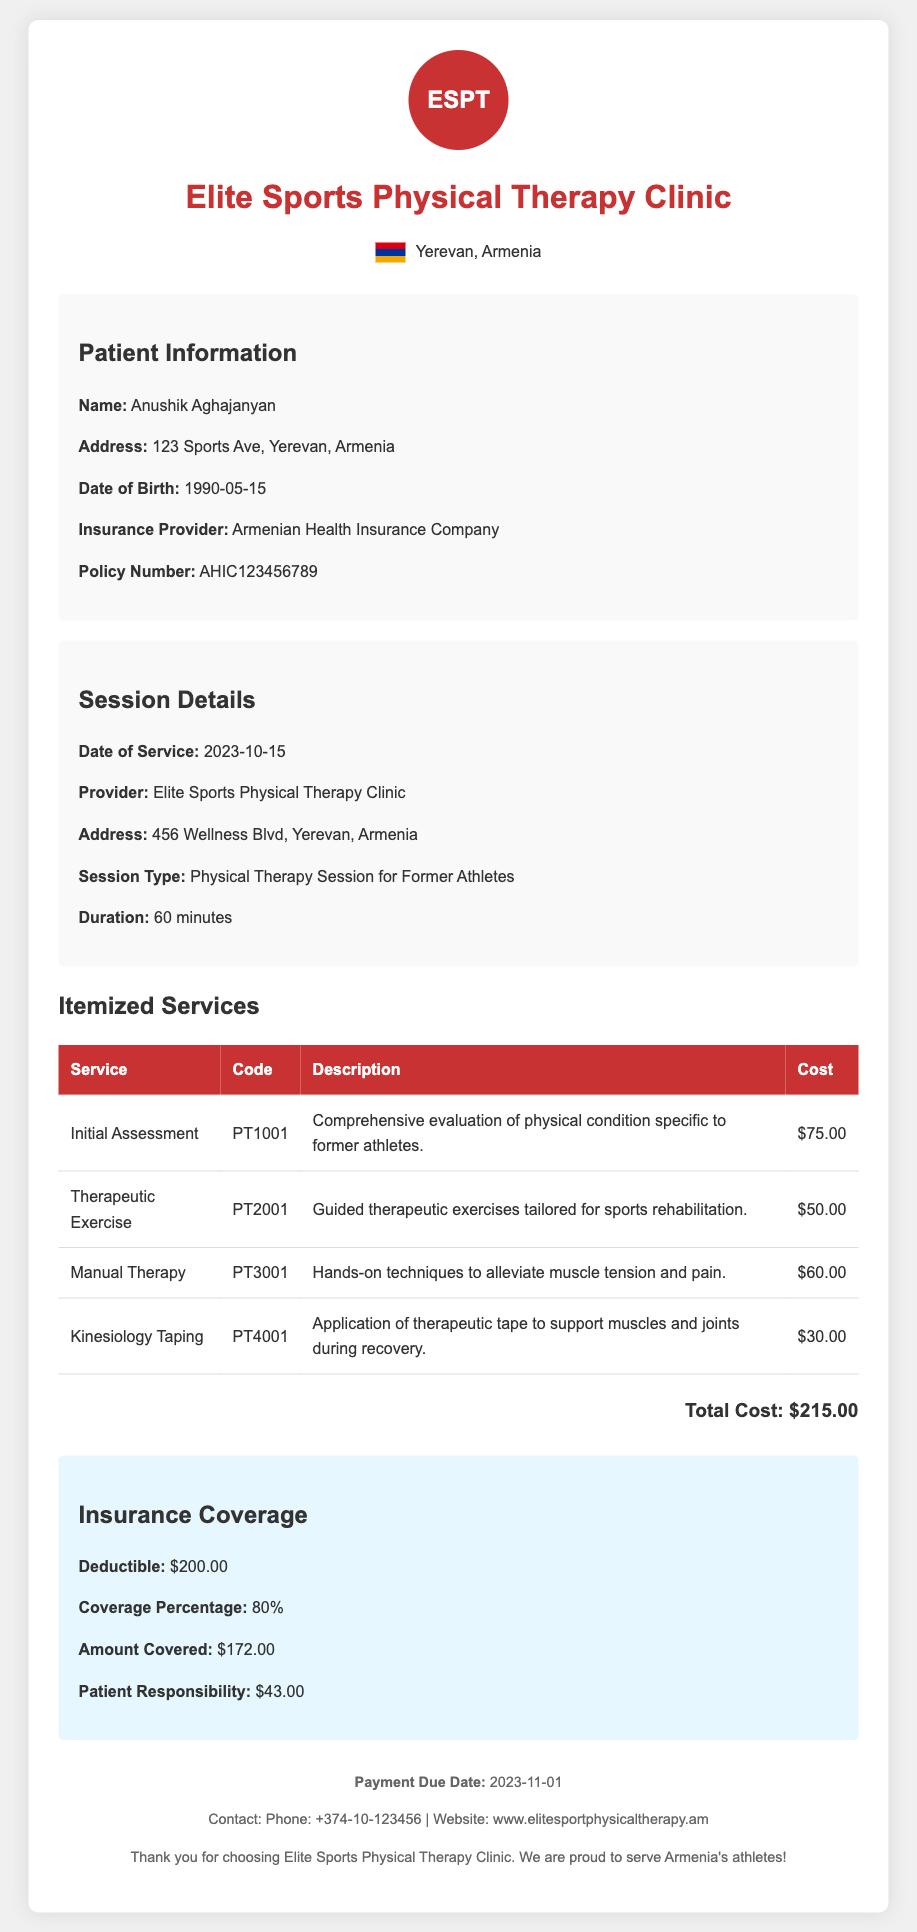What is the patient's name? The document lists the patient's name under the Patient Information section.
Answer: Anushik Aghajanyan What is the total cost of the services? The total cost of the services is presented in the Itemized Services section.
Answer: $215.00 What is the coverage percentage by the insurance? The insurance coverage percentage is specified in the Insurance Coverage section.
Answer: 80% What is the amount covered by the insurance? The amount covered is found in the Insurance Coverage section of the document.
Answer: $172.00 What is the date of service? The date of service is mentioned in the Session Details section.
Answer: 2023-10-15 How much is the patient responsible for after insurance? The patient responsibility amount is detailed in the Insurance Coverage section.
Answer: $43.00 What type of session was provided? The type of session is indicated in the Session Details section of the document.
Answer: Physical Therapy Session for Former Athletes What is the payment due date? The payment due date is listed in the footer of the document.
Answer: 2023-11-01 What is the insurance provider's name? The insurance provider's name can be found in the Patient Information section.
Answer: Armenian Health Insurance Company 